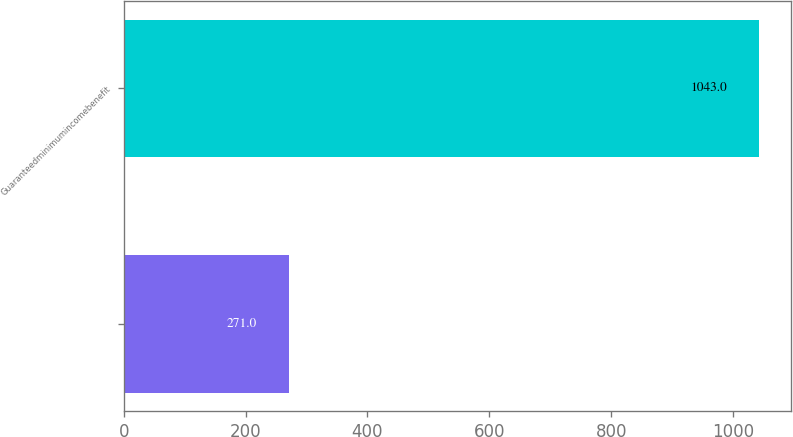Convert chart. <chart><loc_0><loc_0><loc_500><loc_500><bar_chart><ecel><fcel>Guaranteedminimumincomebenefit<nl><fcel>271<fcel>1043<nl></chart> 